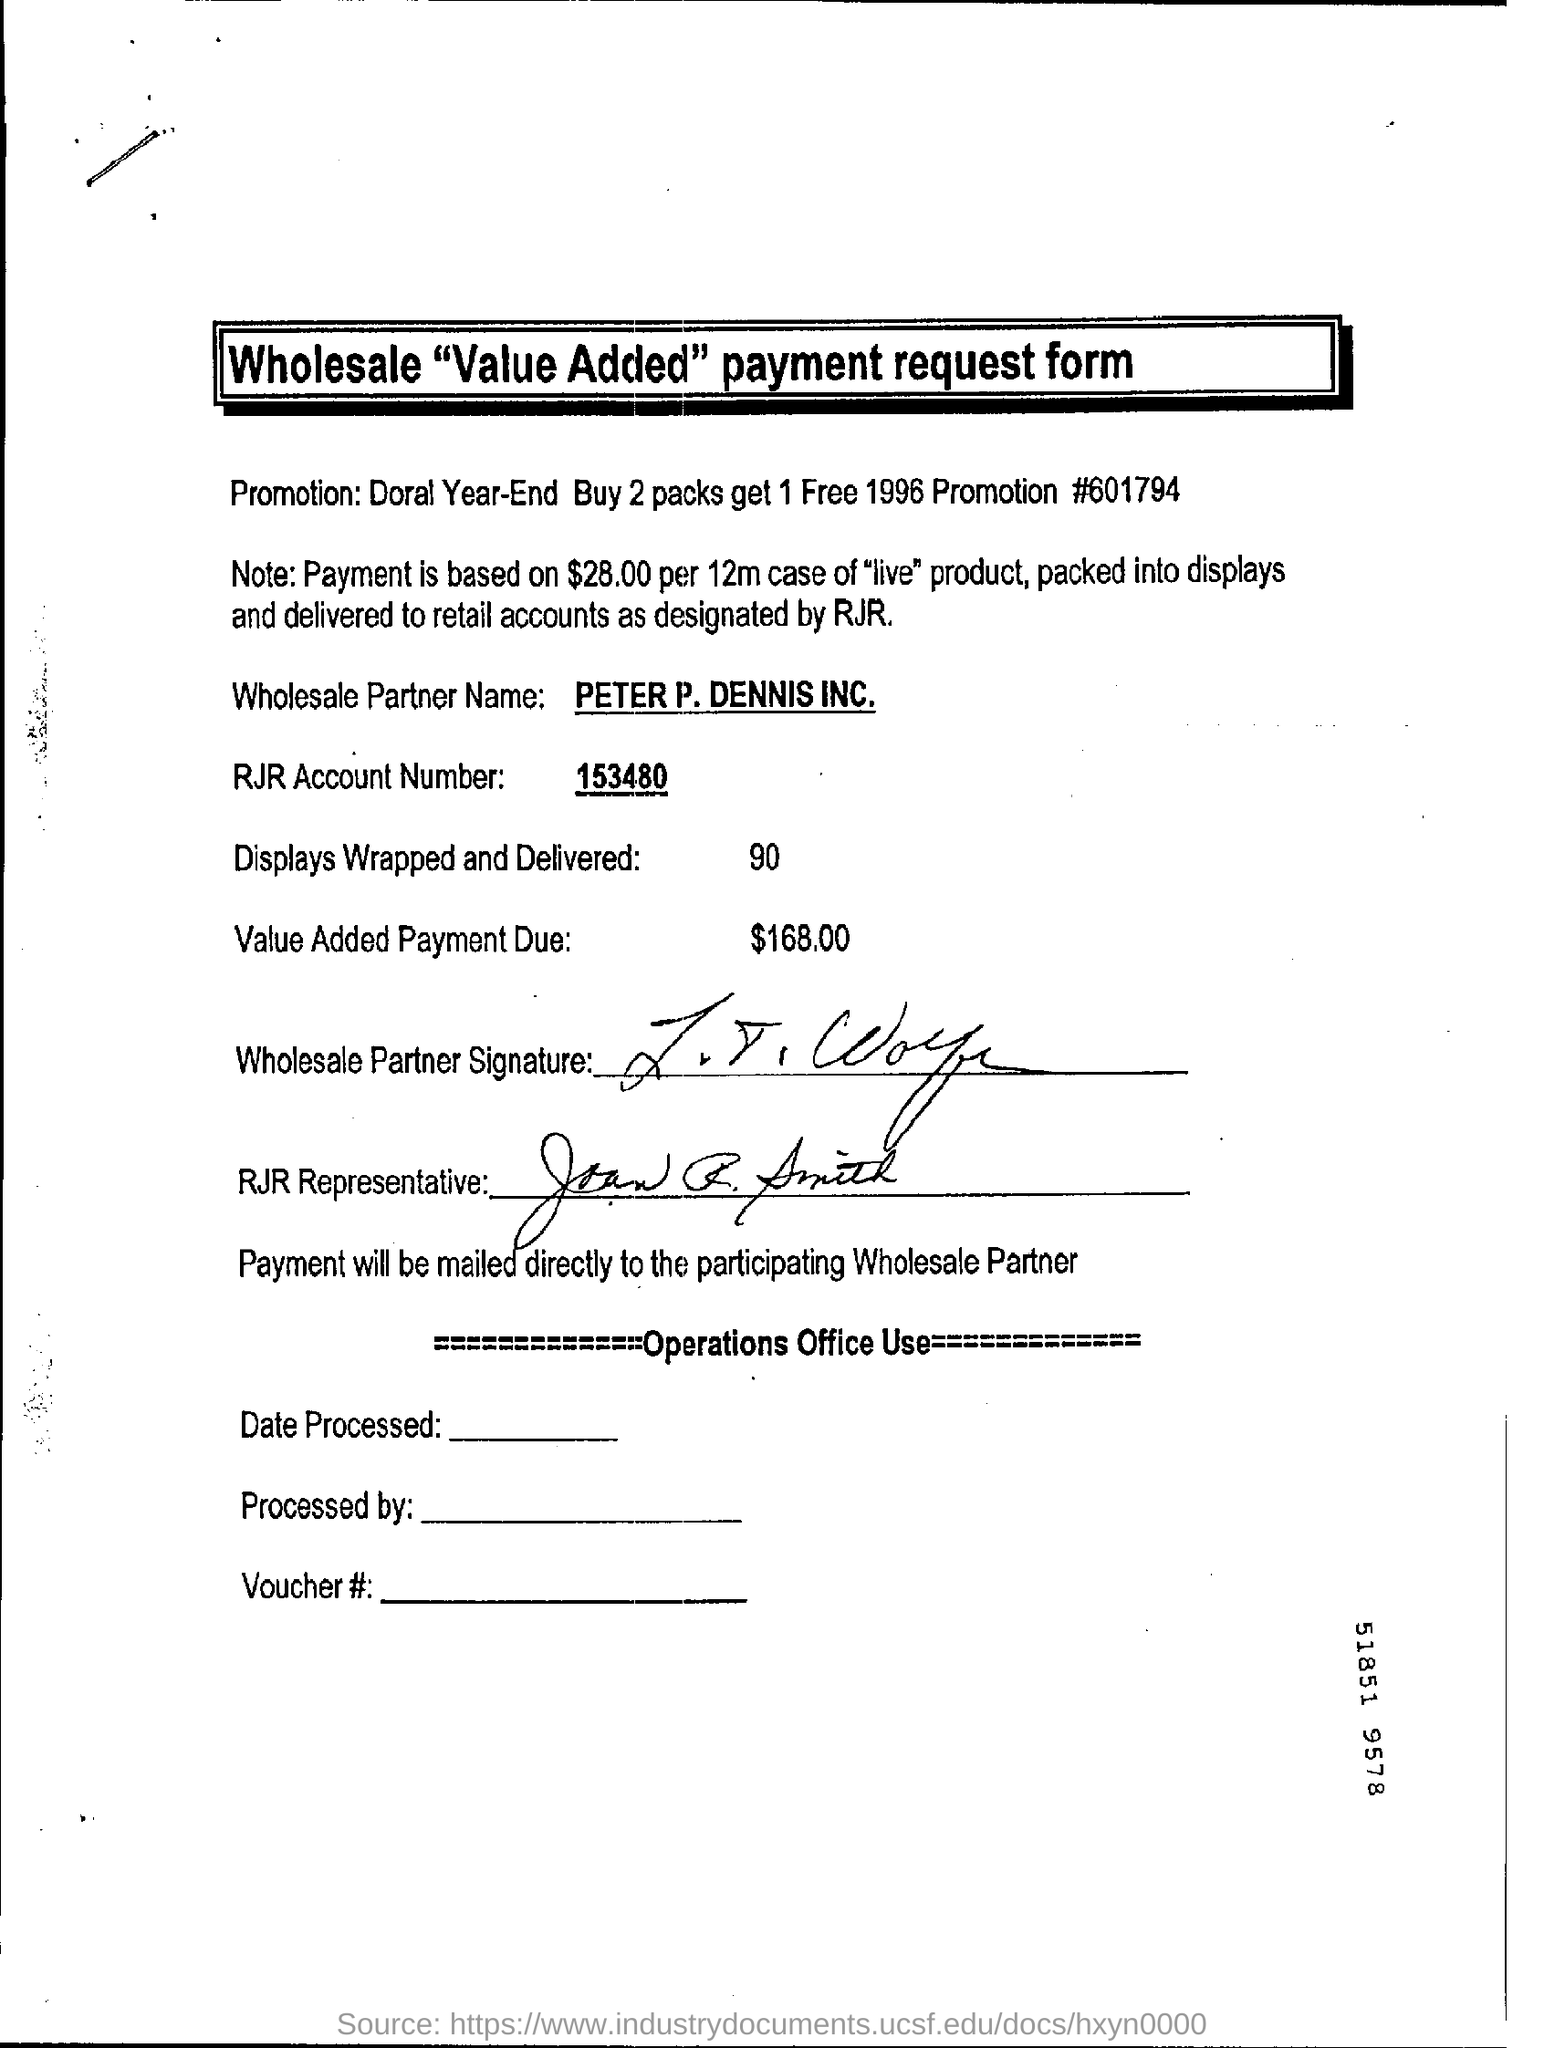Outline some significant characteristics in this image. The RJR Account Number is 153480. The name of the wholesale partner is Peter P. Dennis Inc. 